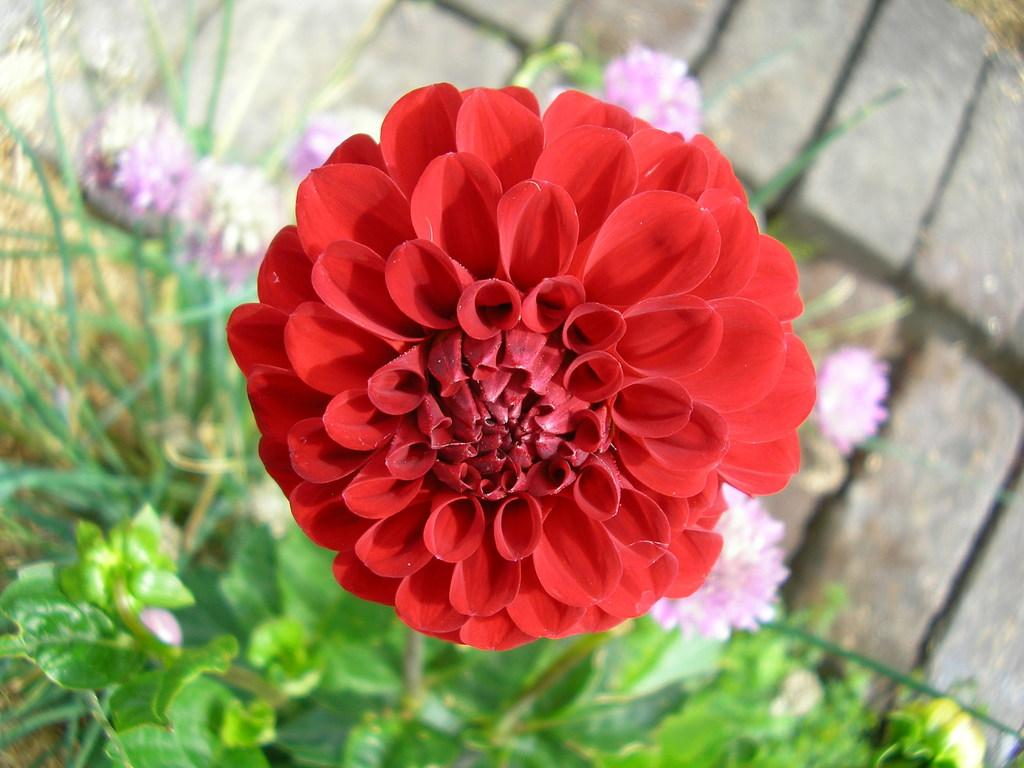What color is the flower that is the main focus of the image? The flower that is the main focus of the image is red. Where is the red flower located? The red flower is on a plant. Are there any other flowers visible in the image? Yes, there are other flowers around the red flower. How is the background of the flowers depicted in the image? The background of the flowers is blurred. Can you see a foot resting on the shelf in the image? There is no foot or shelf present in the image; it features a red flower on a plant with other flowers around it and a blurred background. 